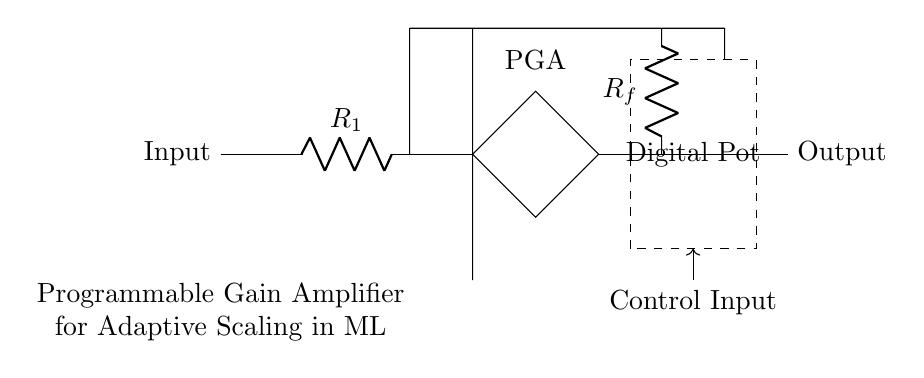What is the input component in the circuit? The input component is labeled as "Input" in the diagram, which connects to a resistor labeled R1.
Answer: Input What type of operational device is used? The circuit uses a "Programmable Gain Amplifier" which is specifically indicated in the diagram near the op-amp symbol.
Answer: Programmable Gain Amplifier What does the feedback resistor Rf do in this circuit? The feedback resistor Rf helps in determining the gain of the amplifier by forming a feedback loop with the operational amplifier, affecting how much of the output signal is fed back to the input.
Answer: Determines gain What role does the digital potentiometer play? The digital potentiometer adjusts the resistance in the feedback network, allowing for programmable gain changes based on control input, facilitating adaptive scaling for different input signal levels.
Answer: Programmable gain What is the output of the circuit labeled as? The output is labeled clearly as "Output" on the right side of the circuit diagram, showing where the amplified signal is taken from.
Answer: Output How is the gain adjusted in this amplifier circuit? The gain is adjusted with the control input connected to the digital potentiometer, which changes the resistance value in the feedback loop thereby altering the gain.
Answer: Control input What is the significance of the dashed rectangle in the circuit? The dashed rectangle encompasses the digital potentiometer, indicating it is a distinguishable component within the circuit responsible for changing gain; this visual cue helps highlight its role.
Answer: Digital Pot 